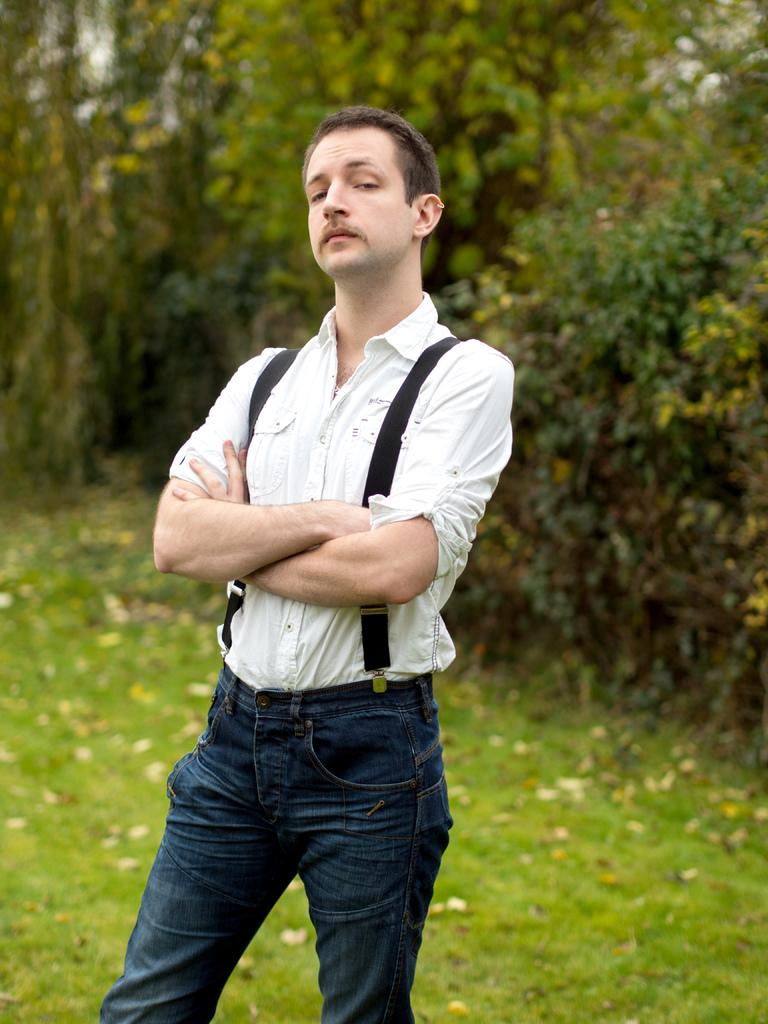What is the man in the image wearing? The man is wearing a white shirt and jeans. What can be seen in the background of the image? There is grassy land and trees in the background of the image. Where is the table located in the image? There is no table present in the image. What type of rod can be seen in the man's hand in the image? There is no rod visible in the man's hand or anywhere in the image. 